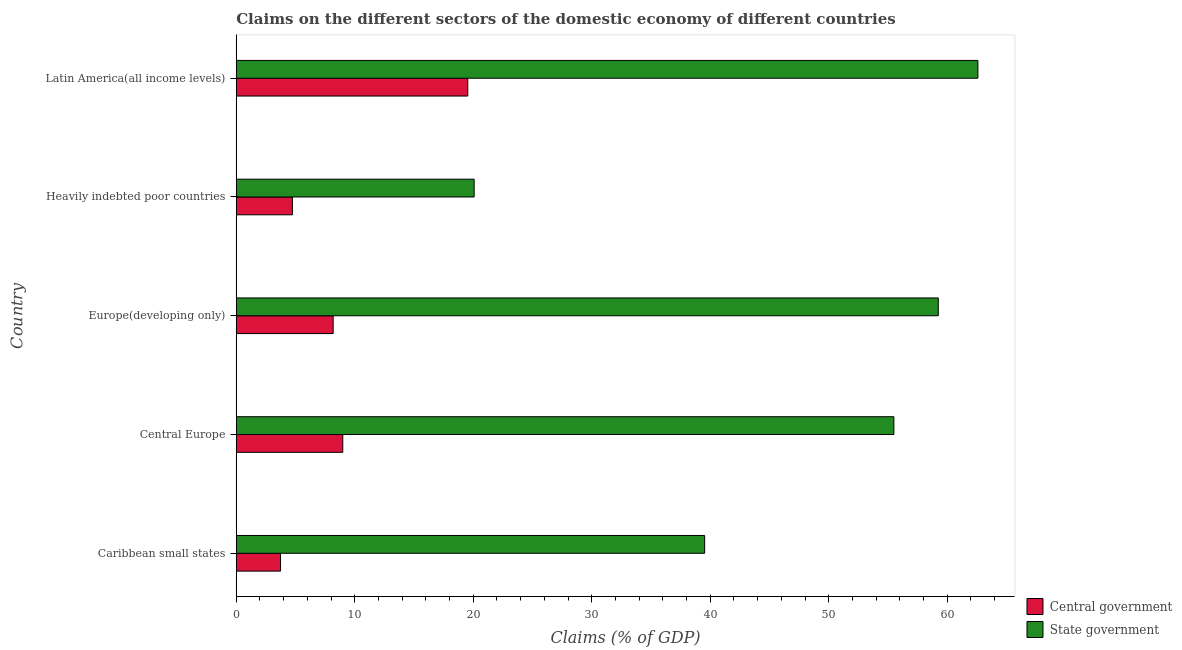How many groups of bars are there?
Offer a very short reply. 5. Are the number of bars per tick equal to the number of legend labels?
Provide a succinct answer. Yes. How many bars are there on the 2nd tick from the top?
Your answer should be very brief. 2. What is the label of the 3rd group of bars from the top?
Your answer should be very brief. Europe(developing only). In how many cases, is the number of bars for a given country not equal to the number of legend labels?
Ensure brevity in your answer.  0. What is the claims on central government in Europe(developing only)?
Make the answer very short. 8.18. Across all countries, what is the maximum claims on central government?
Keep it short and to the point. 19.54. Across all countries, what is the minimum claims on central government?
Provide a succinct answer. 3.74. In which country was the claims on central government maximum?
Your answer should be compact. Latin America(all income levels). In which country was the claims on state government minimum?
Give a very brief answer. Heavily indebted poor countries. What is the total claims on central government in the graph?
Keep it short and to the point. 45.18. What is the difference between the claims on state government in Caribbean small states and that in Latin America(all income levels)?
Your answer should be compact. -23.06. What is the difference between the claims on central government in Heavily indebted poor countries and the claims on state government in Latin America(all income levels)?
Offer a terse response. -57.85. What is the average claims on state government per country?
Your answer should be very brief. 47.39. What is the difference between the claims on central government and claims on state government in Caribbean small states?
Give a very brief answer. -35.79. In how many countries, is the claims on state government greater than 8 %?
Your response must be concise. 5. What is the ratio of the claims on state government in Caribbean small states to that in Latin America(all income levels)?
Your answer should be compact. 0.63. What is the difference between the highest and the second highest claims on central government?
Your answer should be compact. 10.55. What is the difference between the highest and the lowest claims on central government?
Offer a terse response. 15.8. What does the 2nd bar from the top in Europe(developing only) represents?
Your response must be concise. Central government. What does the 2nd bar from the bottom in Caribbean small states represents?
Make the answer very short. State government. Are all the bars in the graph horizontal?
Make the answer very short. Yes. Does the graph contain grids?
Give a very brief answer. No. Where does the legend appear in the graph?
Provide a succinct answer. Bottom right. What is the title of the graph?
Offer a terse response. Claims on the different sectors of the domestic economy of different countries. Does "Under-five" appear as one of the legend labels in the graph?
Make the answer very short. No. What is the label or title of the X-axis?
Your answer should be very brief. Claims (% of GDP). What is the Claims (% of GDP) in Central government in Caribbean small states?
Make the answer very short. 3.74. What is the Claims (% of GDP) in State government in Caribbean small states?
Your answer should be very brief. 39.53. What is the Claims (% of GDP) of Central government in Central Europe?
Your answer should be very brief. 8.99. What is the Claims (% of GDP) in State government in Central Europe?
Provide a short and direct response. 55.5. What is the Claims (% of GDP) in Central government in Europe(developing only)?
Your answer should be compact. 8.18. What is the Claims (% of GDP) in State government in Europe(developing only)?
Your answer should be compact. 59.25. What is the Claims (% of GDP) of Central government in Heavily indebted poor countries?
Ensure brevity in your answer.  4.74. What is the Claims (% of GDP) of State government in Heavily indebted poor countries?
Provide a succinct answer. 20.08. What is the Claims (% of GDP) in Central government in Latin America(all income levels)?
Your response must be concise. 19.54. What is the Claims (% of GDP) in State government in Latin America(all income levels)?
Ensure brevity in your answer.  62.59. Across all countries, what is the maximum Claims (% of GDP) of Central government?
Provide a short and direct response. 19.54. Across all countries, what is the maximum Claims (% of GDP) in State government?
Your answer should be compact. 62.59. Across all countries, what is the minimum Claims (% of GDP) of Central government?
Offer a terse response. 3.74. Across all countries, what is the minimum Claims (% of GDP) in State government?
Give a very brief answer. 20.08. What is the total Claims (% of GDP) in Central government in the graph?
Provide a succinct answer. 45.18. What is the total Claims (% of GDP) in State government in the graph?
Your response must be concise. 236.94. What is the difference between the Claims (% of GDP) of Central government in Caribbean small states and that in Central Europe?
Your answer should be very brief. -5.25. What is the difference between the Claims (% of GDP) in State government in Caribbean small states and that in Central Europe?
Ensure brevity in your answer.  -15.97. What is the difference between the Claims (% of GDP) of Central government in Caribbean small states and that in Europe(developing only)?
Ensure brevity in your answer.  -4.44. What is the difference between the Claims (% of GDP) of State government in Caribbean small states and that in Europe(developing only)?
Your answer should be very brief. -19.72. What is the difference between the Claims (% of GDP) in Central government in Caribbean small states and that in Heavily indebted poor countries?
Offer a very short reply. -1. What is the difference between the Claims (% of GDP) of State government in Caribbean small states and that in Heavily indebted poor countries?
Your answer should be very brief. 19.45. What is the difference between the Claims (% of GDP) of Central government in Caribbean small states and that in Latin America(all income levels)?
Offer a very short reply. -15.8. What is the difference between the Claims (% of GDP) of State government in Caribbean small states and that in Latin America(all income levels)?
Offer a very short reply. -23.06. What is the difference between the Claims (% of GDP) of Central government in Central Europe and that in Europe(developing only)?
Keep it short and to the point. 0.81. What is the difference between the Claims (% of GDP) in State government in Central Europe and that in Europe(developing only)?
Keep it short and to the point. -3.75. What is the difference between the Claims (% of GDP) of Central government in Central Europe and that in Heavily indebted poor countries?
Ensure brevity in your answer.  4.25. What is the difference between the Claims (% of GDP) in State government in Central Europe and that in Heavily indebted poor countries?
Make the answer very short. 35.42. What is the difference between the Claims (% of GDP) of Central government in Central Europe and that in Latin America(all income levels)?
Keep it short and to the point. -10.55. What is the difference between the Claims (% of GDP) of State government in Central Europe and that in Latin America(all income levels)?
Give a very brief answer. -7.09. What is the difference between the Claims (% of GDP) in Central government in Europe(developing only) and that in Heavily indebted poor countries?
Give a very brief answer. 3.44. What is the difference between the Claims (% of GDP) in State government in Europe(developing only) and that in Heavily indebted poor countries?
Give a very brief answer. 39.17. What is the difference between the Claims (% of GDP) of Central government in Europe(developing only) and that in Latin America(all income levels)?
Provide a succinct answer. -11.36. What is the difference between the Claims (% of GDP) in State government in Europe(developing only) and that in Latin America(all income levels)?
Ensure brevity in your answer.  -3.34. What is the difference between the Claims (% of GDP) in Central government in Heavily indebted poor countries and that in Latin America(all income levels)?
Your answer should be compact. -14.8. What is the difference between the Claims (% of GDP) in State government in Heavily indebted poor countries and that in Latin America(all income levels)?
Offer a very short reply. -42.51. What is the difference between the Claims (% of GDP) of Central government in Caribbean small states and the Claims (% of GDP) of State government in Central Europe?
Provide a succinct answer. -51.76. What is the difference between the Claims (% of GDP) in Central government in Caribbean small states and the Claims (% of GDP) in State government in Europe(developing only)?
Provide a succinct answer. -55.51. What is the difference between the Claims (% of GDP) in Central government in Caribbean small states and the Claims (% of GDP) in State government in Heavily indebted poor countries?
Offer a terse response. -16.34. What is the difference between the Claims (% of GDP) in Central government in Caribbean small states and the Claims (% of GDP) in State government in Latin America(all income levels)?
Your answer should be very brief. -58.85. What is the difference between the Claims (% of GDP) in Central government in Central Europe and the Claims (% of GDP) in State government in Europe(developing only)?
Provide a succinct answer. -50.26. What is the difference between the Claims (% of GDP) in Central government in Central Europe and the Claims (% of GDP) in State government in Heavily indebted poor countries?
Keep it short and to the point. -11.09. What is the difference between the Claims (% of GDP) of Central government in Central Europe and the Claims (% of GDP) of State government in Latin America(all income levels)?
Your answer should be very brief. -53.6. What is the difference between the Claims (% of GDP) of Central government in Europe(developing only) and the Claims (% of GDP) of State government in Heavily indebted poor countries?
Provide a succinct answer. -11.9. What is the difference between the Claims (% of GDP) of Central government in Europe(developing only) and the Claims (% of GDP) of State government in Latin America(all income levels)?
Your response must be concise. -54.41. What is the difference between the Claims (% of GDP) in Central government in Heavily indebted poor countries and the Claims (% of GDP) in State government in Latin America(all income levels)?
Provide a short and direct response. -57.85. What is the average Claims (% of GDP) in Central government per country?
Make the answer very short. 9.04. What is the average Claims (% of GDP) of State government per country?
Offer a terse response. 47.39. What is the difference between the Claims (% of GDP) in Central government and Claims (% of GDP) in State government in Caribbean small states?
Give a very brief answer. -35.79. What is the difference between the Claims (% of GDP) in Central government and Claims (% of GDP) in State government in Central Europe?
Keep it short and to the point. -46.51. What is the difference between the Claims (% of GDP) of Central government and Claims (% of GDP) of State government in Europe(developing only)?
Offer a terse response. -51.07. What is the difference between the Claims (% of GDP) in Central government and Claims (% of GDP) in State government in Heavily indebted poor countries?
Your answer should be compact. -15.34. What is the difference between the Claims (% of GDP) of Central government and Claims (% of GDP) of State government in Latin America(all income levels)?
Ensure brevity in your answer.  -43.05. What is the ratio of the Claims (% of GDP) in Central government in Caribbean small states to that in Central Europe?
Give a very brief answer. 0.42. What is the ratio of the Claims (% of GDP) in State government in Caribbean small states to that in Central Europe?
Ensure brevity in your answer.  0.71. What is the ratio of the Claims (% of GDP) in Central government in Caribbean small states to that in Europe(developing only)?
Make the answer very short. 0.46. What is the ratio of the Claims (% of GDP) in State government in Caribbean small states to that in Europe(developing only)?
Offer a terse response. 0.67. What is the ratio of the Claims (% of GDP) of Central government in Caribbean small states to that in Heavily indebted poor countries?
Offer a terse response. 0.79. What is the ratio of the Claims (% of GDP) of State government in Caribbean small states to that in Heavily indebted poor countries?
Offer a terse response. 1.97. What is the ratio of the Claims (% of GDP) of Central government in Caribbean small states to that in Latin America(all income levels)?
Offer a very short reply. 0.19. What is the ratio of the Claims (% of GDP) of State government in Caribbean small states to that in Latin America(all income levels)?
Your answer should be compact. 0.63. What is the ratio of the Claims (% of GDP) in Central government in Central Europe to that in Europe(developing only)?
Make the answer very short. 1.1. What is the ratio of the Claims (% of GDP) in State government in Central Europe to that in Europe(developing only)?
Keep it short and to the point. 0.94. What is the ratio of the Claims (% of GDP) of Central government in Central Europe to that in Heavily indebted poor countries?
Provide a short and direct response. 1.9. What is the ratio of the Claims (% of GDP) of State government in Central Europe to that in Heavily indebted poor countries?
Make the answer very short. 2.76. What is the ratio of the Claims (% of GDP) of Central government in Central Europe to that in Latin America(all income levels)?
Make the answer very short. 0.46. What is the ratio of the Claims (% of GDP) of State government in Central Europe to that in Latin America(all income levels)?
Make the answer very short. 0.89. What is the ratio of the Claims (% of GDP) in Central government in Europe(developing only) to that in Heavily indebted poor countries?
Your response must be concise. 1.73. What is the ratio of the Claims (% of GDP) of State government in Europe(developing only) to that in Heavily indebted poor countries?
Offer a terse response. 2.95. What is the ratio of the Claims (% of GDP) in Central government in Europe(developing only) to that in Latin America(all income levels)?
Make the answer very short. 0.42. What is the ratio of the Claims (% of GDP) of State government in Europe(developing only) to that in Latin America(all income levels)?
Offer a terse response. 0.95. What is the ratio of the Claims (% of GDP) of Central government in Heavily indebted poor countries to that in Latin America(all income levels)?
Provide a succinct answer. 0.24. What is the ratio of the Claims (% of GDP) in State government in Heavily indebted poor countries to that in Latin America(all income levels)?
Ensure brevity in your answer.  0.32. What is the difference between the highest and the second highest Claims (% of GDP) of Central government?
Keep it short and to the point. 10.55. What is the difference between the highest and the second highest Claims (% of GDP) of State government?
Give a very brief answer. 3.34. What is the difference between the highest and the lowest Claims (% of GDP) of Central government?
Give a very brief answer. 15.8. What is the difference between the highest and the lowest Claims (% of GDP) of State government?
Your answer should be compact. 42.51. 